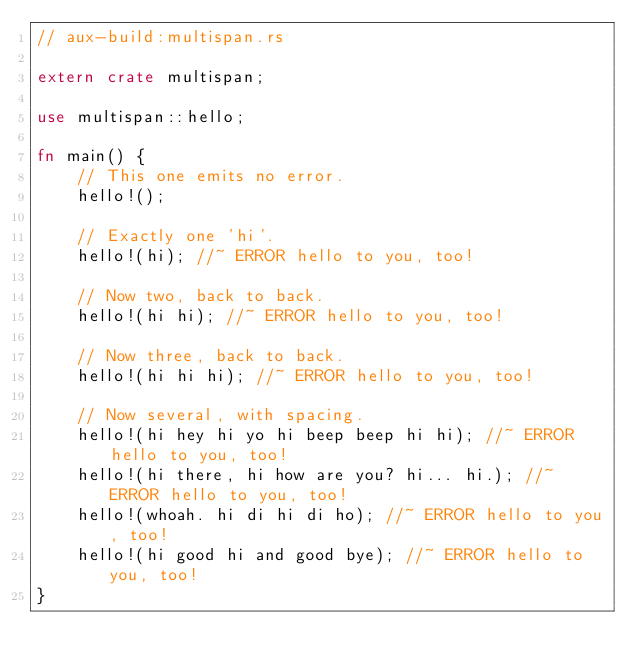Convert code to text. <code><loc_0><loc_0><loc_500><loc_500><_Rust_>// aux-build:multispan.rs

extern crate multispan;

use multispan::hello;

fn main() {
    // This one emits no error.
    hello!();

    // Exactly one 'hi'.
    hello!(hi); //~ ERROR hello to you, too!

    // Now two, back to back.
    hello!(hi hi); //~ ERROR hello to you, too!

    // Now three, back to back.
    hello!(hi hi hi); //~ ERROR hello to you, too!

    // Now several, with spacing.
    hello!(hi hey hi yo hi beep beep hi hi); //~ ERROR hello to you, too!
    hello!(hi there, hi how are you? hi... hi.); //~ ERROR hello to you, too!
    hello!(whoah. hi di hi di ho); //~ ERROR hello to you, too!
    hello!(hi good hi and good bye); //~ ERROR hello to you, too!
}
</code> 